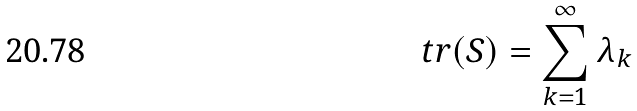Convert formula to latex. <formula><loc_0><loc_0><loc_500><loc_500>\ t r ( S ) = \sum _ { k = 1 } ^ { \infty } \lambda _ { k }</formula> 